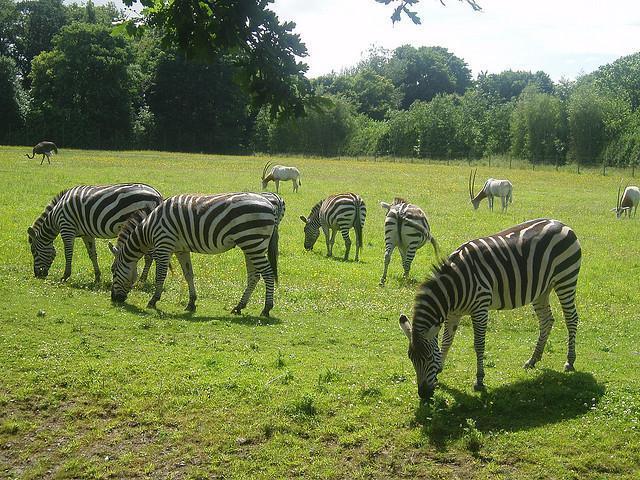How many types of animals are shown?
Give a very brief answer. 3. How many zebras are there?
Give a very brief answer. 5. How many zebras are in the picture?
Give a very brief answer. 5. 